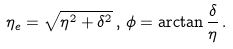<formula> <loc_0><loc_0><loc_500><loc_500>\eta _ { e } = \sqrt { \eta ^ { 2 } + \delta ^ { 2 } } \, , \, \phi = \arctan \frac { \delta } { \eta } \, .</formula> 